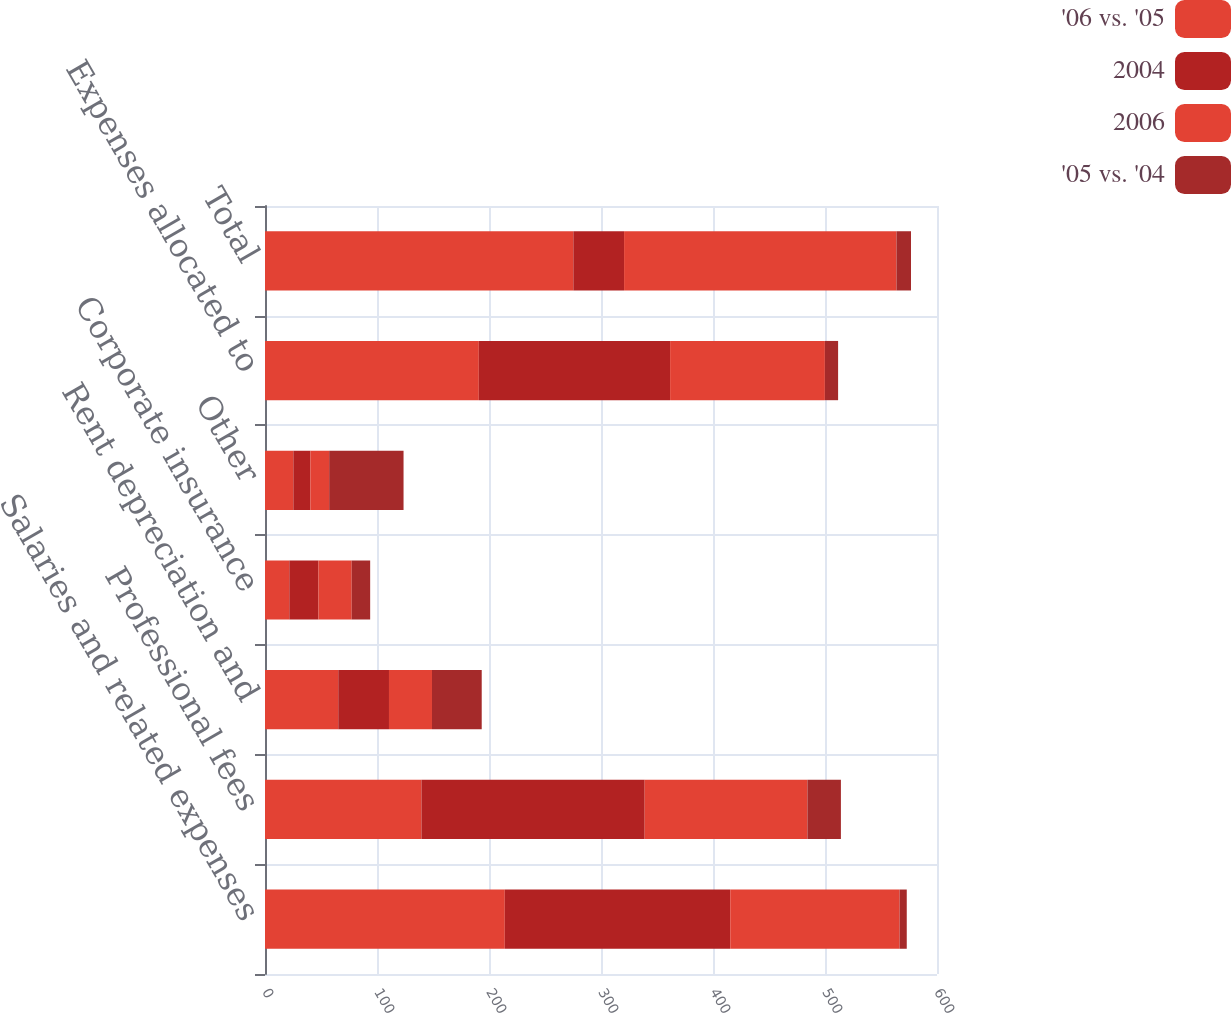<chart> <loc_0><loc_0><loc_500><loc_500><stacked_bar_chart><ecel><fcel>Salaries and related expenses<fcel>Professional fees<fcel>Rent depreciation and<fcel>Corporate insurance<fcel>Other<fcel>Expenses allocated to<fcel>Total<nl><fcel>'06 vs. '05<fcel>214.1<fcel>139.7<fcel>65.4<fcel>21.7<fcel>25.3<fcel>190.9<fcel>275.3<nl><fcel>2004<fcel>201.3<fcel>199.3<fcel>45.3<fcel>26<fcel>15.2<fcel>170.8<fcel>45.3<nl><fcel>2006<fcel>151.2<fcel>145.3<fcel>38.4<fcel>29.7<fcel>16.8<fcel>138.2<fcel>243.2<nl><fcel>'05 vs. '04<fcel>6.4<fcel>29.9<fcel>44.4<fcel>16.5<fcel>66.4<fcel>11.8<fcel>13<nl></chart> 